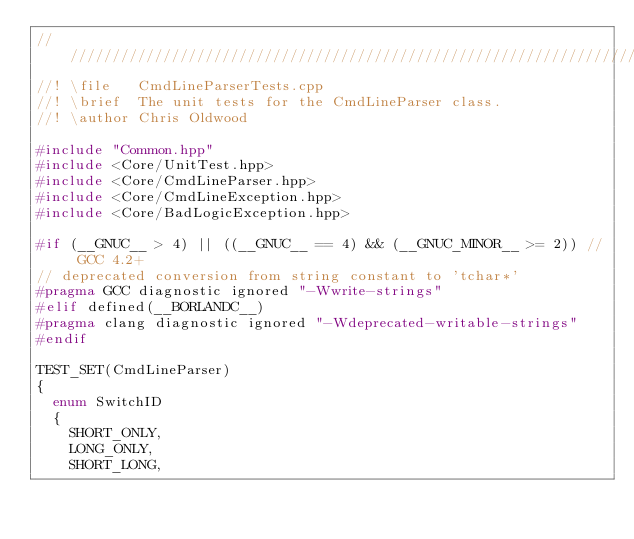Convert code to text. <code><loc_0><loc_0><loc_500><loc_500><_C++_>////////////////////////////////////////////////////////////////////////////////
//! \file   CmdLineParserTests.cpp
//! \brief  The unit tests for the CmdLineParser class.
//! \author Chris Oldwood

#include "Common.hpp"
#include <Core/UnitTest.hpp>
#include <Core/CmdLineParser.hpp>
#include <Core/CmdLineException.hpp>
#include <Core/BadLogicException.hpp>

#if (__GNUC__ > 4) || ((__GNUC__ == 4) && (__GNUC_MINOR__ >= 2)) // GCC 4.2+
// deprecated conversion from string constant to 'tchar*'
#pragma GCC diagnostic ignored "-Wwrite-strings"
#elif defined(__BORLANDC__)
#pragma clang diagnostic ignored "-Wdeprecated-writable-strings"
#endif

TEST_SET(CmdLineParser)
{
	enum SwitchID
	{
		SHORT_ONLY,
		LONG_ONLY,
		SHORT_LONG,</code> 